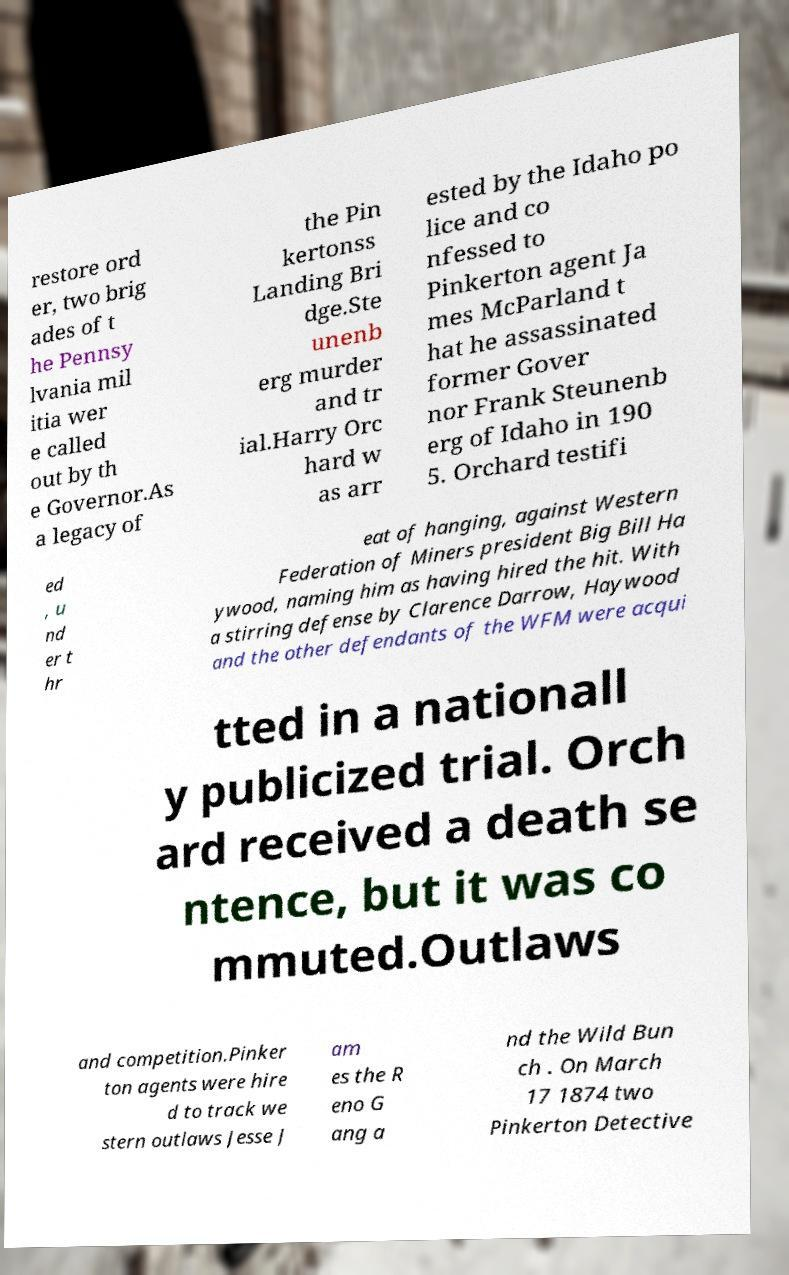Could you assist in decoding the text presented in this image and type it out clearly? restore ord er, two brig ades of t he Pennsy lvania mil itia wer e called out by th e Governor.As a legacy of the Pin kertonss Landing Bri dge.Ste unenb erg murder and tr ial.Harry Orc hard w as arr ested by the Idaho po lice and co nfessed to Pinkerton agent Ja mes McParland t hat he assassinated former Gover nor Frank Steunenb erg of Idaho in 190 5. Orchard testifi ed , u nd er t hr eat of hanging, against Western Federation of Miners president Big Bill Ha ywood, naming him as having hired the hit. With a stirring defense by Clarence Darrow, Haywood and the other defendants of the WFM were acqui tted in a nationall y publicized trial. Orch ard received a death se ntence, but it was co mmuted.Outlaws and competition.Pinker ton agents were hire d to track we stern outlaws Jesse J am es the R eno G ang a nd the Wild Bun ch . On March 17 1874 two Pinkerton Detective 